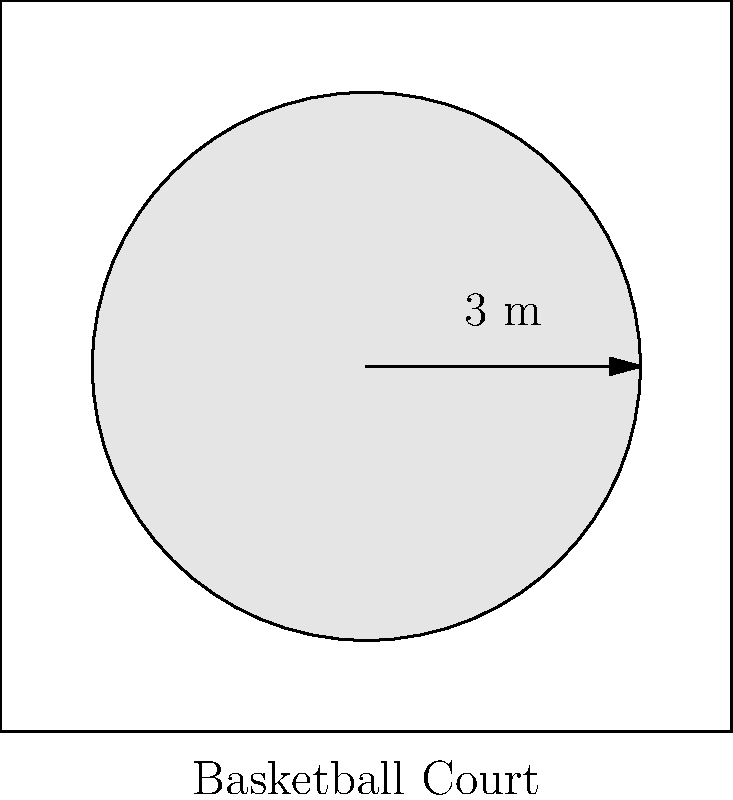During a timeout, you want to create a circular team huddle zone on the court. If the radius of this zone is 3 meters, what is the area of the huddle zone? Round your answer to the nearest square meter. To solve this problem, we need to follow these steps:

1) The formula for the area of a circle is $A = \pi r^2$, where $r$ is the radius.

2) We are given that the radius is 3 meters.

3) Let's substitute this into our formula:
   $A = \pi (3)^2$

4) Simplify:
   $A = \pi (9)$
   $A = 9\pi$

5) Now, let's calculate this:
   $A = 9 \times 3.14159...$
   $A \approx 28.27$ square meters

6) Rounding to the nearest square meter:
   $A \approx 28$ square meters

This huddle zone provides enough space for the team to gather comfortably while discussing strategies, fostering team chemistry, and allowing all players, including role players, to be included in the huddle.
Answer: 28 square meters 